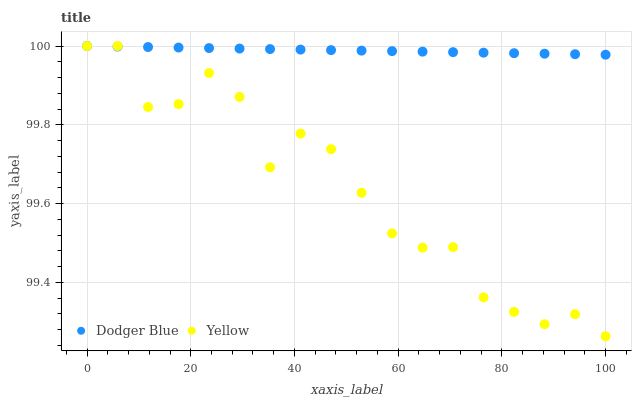Does Yellow have the minimum area under the curve?
Answer yes or no. Yes. Does Dodger Blue have the maximum area under the curve?
Answer yes or no. Yes. Does Yellow have the maximum area under the curve?
Answer yes or no. No. Is Dodger Blue the smoothest?
Answer yes or no. Yes. Is Yellow the roughest?
Answer yes or no. Yes. Is Yellow the smoothest?
Answer yes or no. No. Does Yellow have the lowest value?
Answer yes or no. Yes. Does Yellow have the highest value?
Answer yes or no. Yes. Does Yellow intersect Dodger Blue?
Answer yes or no. Yes. Is Yellow less than Dodger Blue?
Answer yes or no. No. Is Yellow greater than Dodger Blue?
Answer yes or no. No. 